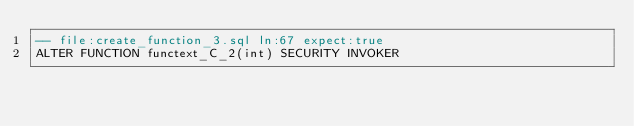<code> <loc_0><loc_0><loc_500><loc_500><_SQL_>-- file:create_function_3.sql ln:67 expect:true
ALTER FUNCTION functext_C_2(int) SECURITY INVOKER
</code> 